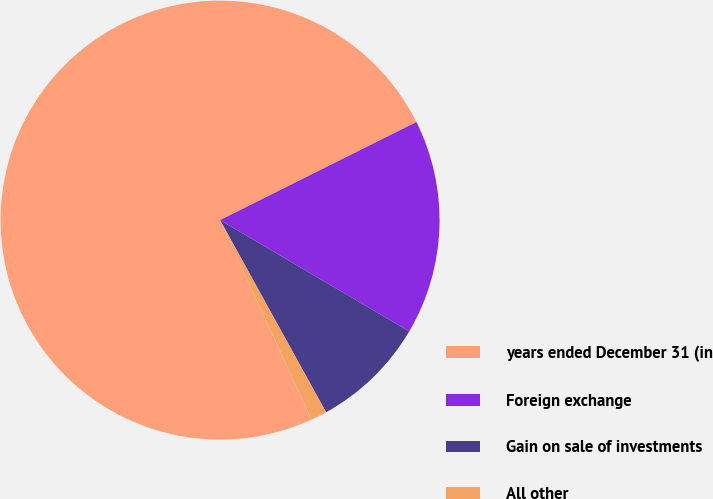<chart> <loc_0><loc_0><loc_500><loc_500><pie_chart><fcel>years ended December 31 (in<fcel>Foreign exchange<fcel>Gain on sale of investments<fcel>All other<nl><fcel>74.47%<fcel>15.84%<fcel>8.51%<fcel>1.18%<nl></chart> 